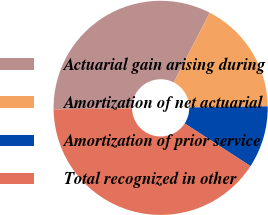Convert chart to OTSL. <chart><loc_0><loc_0><loc_500><loc_500><pie_chart><fcel>Actuarial gain arising during<fcel>Amortization of net actuarial<fcel>Amortization of prior service<fcel>Total recognized in other<nl><fcel>32.81%<fcel>17.19%<fcel>9.38%<fcel>40.62%<nl></chart> 